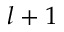Convert formula to latex. <formula><loc_0><loc_0><loc_500><loc_500>l + 1</formula> 